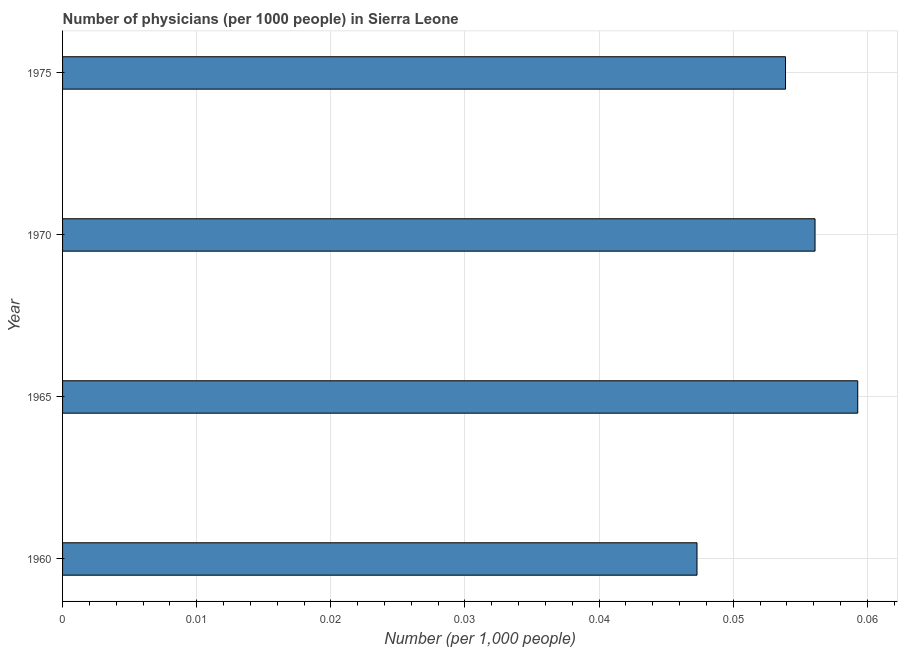Does the graph contain any zero values?
Give a very brief answer. No. What is the title of the graph?
Provide a succinct answer. Number of physicians (per 1000 people) in Sierra Leone. What is the label or title of the X-axis?
Your answer should be very brief. Number (per 1,0 people). What is the label or title of the Y-axis?
Ensure brevity in your answer.  Year. What is the number of physicians in 1960?
Provide a short and direct response. 0.05. Across all years, what is the maximum number of physicians?
Keep it short and to the point. 0.06. Across all years, what is the minimum number of physicians?
Provide a succinct answer. 0.05. In which year was the number of physicians maximum?
Your answer should be compact. 1965. What is the sum of the number of physicians?
Offer a terse response. 0.22. What is the difference between the number of physicians in 1970 and 1975?
Offer a terse response. 0. What is the average number of physicians per year?
Give a very brief answer. 0.05. What is the median number of physicians?
Provide a short and direct response. 0.05. In how many years, is the number of physicians greater than 0.036 ?
Provide a succinct answer. 4. What is the ratio of the number of physicians in 1960 to that in 1975?
Your answer should be very brief. 0.88. Is the number of physicians in 1970 less than that in 1975?
Ensure brevity in your answer.  No. Is the difference between the number of physicians in 1960 and 1970 greater than the difference between any two years?
Your answer should be very brief. No. What is the difference between the highest and the second highest number of physicians?
Keep it short and to the point. 0. What is the difference between the highest and the lowest number of physicians?
Provide a short and direct response. 0.01. In how many years, is the number of physicians greater than the average number of physicians taken over all years?
Make the answer very short. 2. How many bars are there?
Offer a terse response. 4. What is the Number (per 1,000 people) of 1960?
Your answer should be very brief. 0.05. What is the Number (per 1,000 people) in 1965?
Your answer should be very brief. 0.06. What is the Number (per 1,000 people) in 1970?
Your response must be concise. 0.06. What is the Number (per 1,000 people) of 1975?
Make the answer very short. 0.05. What is the difference between the Number (per 1,000 people) in 1960 and 1965?
Offer a very short reply. -0.01. What is the difference between the Number (per 1,000 people) in 1960 and 1970?
Provide a succinct answer. -0.01. What is the difference between the Number (per 1,000 people) in 1960 and 1975?
Provide a short and direct response. -0.01. What is the difference between the Number (per 1,000 people) in 1965 and 1970?
Keep it short and to the point. 0. What is the difference between the Number (per 1,000 people) in 1965 and 1975?
Keep it short and to the point. 0.01. What is the difference between the Number (per 1,000 people) in 1970 and 1975?
Your answer should be very brief. 0. What is the ratio of the Number (per 1,000 people) in 1960 to that in 1965?
Your answer should be compact. 0.8. What is the ratio of the Number (per 1,000 people) in 1960 to that in 1970?
Offer a very short reply. 0.84. What is the ratio of the Number (per 1,000 people) in 1960 to that in 1975?
Offer a very short reply. 0.88. What is the ratio of the Number (per 1,000 people) in 1965 to that in 1970?
Offer a terse response. 1.06. What is the ratio of the Number (per 1,000 people) in 1970 to that in 1975?
Keep it short and to the point. 1.04. 